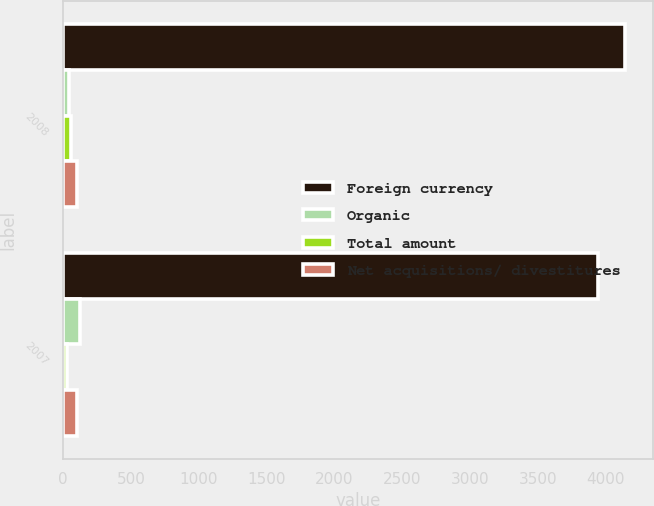Convert chart. <chart><loc_0><loc_0><loc_500><loc_500><stacked_bar_chart><ecel><fcel>2008<fcel>2007<nl><fcel>Foreign currency<fcel>4139.2<fcel>3944.1<nl><fcel>Organic<fcel>40.8<fcel>122.2<nl><fcel>Total amount<fcel>59.4<fcel>32.5<nl><fcel>Net acquisitions/ divestitures<fcel>103.2<fcel>105.4<nl></chart> 